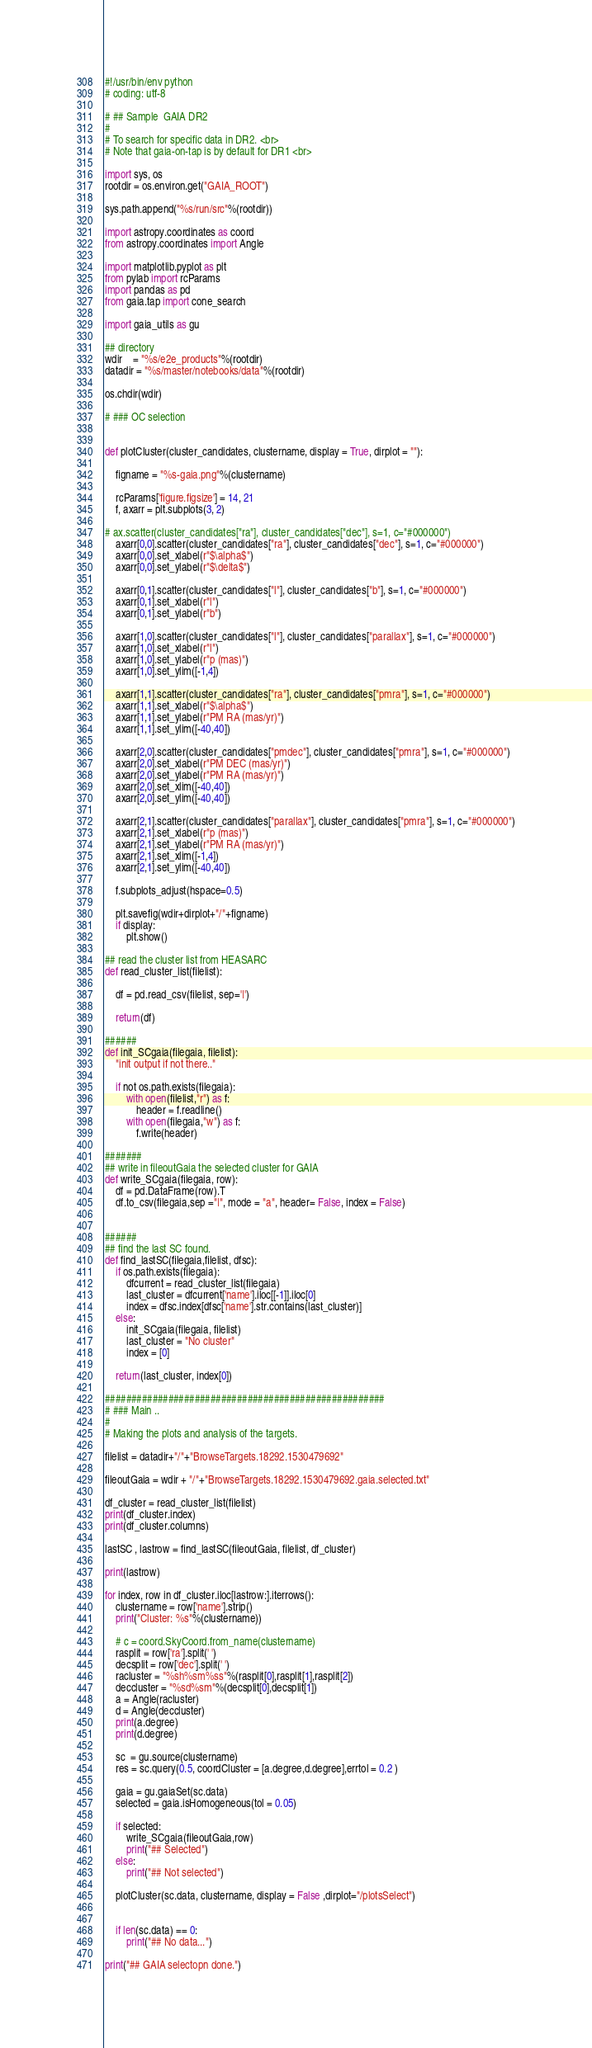<code> <loc_0><loc_0><loc_500><loc_500><_Python_>#!/usr/bin/env python
# coding: utf-8

# ## Sample  GAIA DR2
#
# To search for specific data in DR2. <br>
# Note that gaia-on-tap is by default for DR1 <br>

import sys, os
rootdir = os.environ.get("GAIA_ROOT")

sys.path.append("%s/run/src"%(rootdir))

import astropy.coordinates as coord
from astropy.coordinates import Angle

import matplotlib.pyplot as plt
from pylab import rcParams
import pandas as pd
from gaia.tap import cone_search

import gaia_utils as gu

## directory
wdir    = "%s/e2e_products"%(rootdir)
datadir = "%s/master/notebooks/data"%(rootdir)

os.chdir(wdir)

# ### OC selection


def plotCluster(cluster_candidates, clustername, display = True, dirplot = ""):

    figname = "%s-gaia.png"%(clustername)

    rcParams['figure.figsize'] = 14, 21
    f, axarr = plt.subplots(3, 2)

# ax.scatter(cluster_candidates["ra"], cluster_candidates["dec"], s=1, c="#000000")
    axarr[0,0].scatter(cluster_candidates["ra"], cluster_candidates["dec"], s=1, c="#000000")
    axarr[0,0].set_xlabel(r"$\alpha$")
    axarr[0,0].set_ylabel(r"$\delta$")

    axarr[0,1].scatter(cluster_candidates["l"], cluster_candidates["b"], s=1, c="#000000")
    axarr[0,1].set_xlabel(r"l")
    axarr[0,1].set_ylabel(r"b")

    axarr[1,0].scatter(cluster_candidates["l"], cluster_candidates["parallax"], s=1, c="#000000")
    axarr[1,0].set_xlabel(r"l")
    axarr[1,0].set_ylabel(r"p (mas)")
    axarr[1,0].set_ylim([-1,4])

    axarr[1,1].scatter(cluster_candidates["ra"], cluster_candidates["pmra"], s=1, c="#000000")
    axarr[1,1].set_xlabel(r"$\alpha$")
    axarr[1,1].set_ylabel(r"PM RA (mas/yr)")
    axarr[1,1].set_ylim([-40,40])

    axarr[2,0].scatter(cluster_candidates["pmdec"], cluster_candidates["pmra"], s=1, c="#000000")
    axarr[2,0].set_xlabel(r"PM DEC (mas/yr)")
    axarr[2,0].set_ylabel(r"PM RA (mas/yr)")
    axarr[2,0].set_xlim([-40,40])
    axarr[2,0].set_ylim([-40,40])

    axarr[2,1].scatter(cluster_candidates["parallax"], cluster_candidates["pmra"], s=1, c="#000000")
    axarr[2,1].set_xlabel(r"p (mas)")
    axarr[2,1].set_ylabel(r"PM RA (mas/yr)")
    axarr[2,1].set_xlim([-1,4])
    axarr[2,1].set_ylim([-40,40])

    f.subplots_adjust(hspace=0.5)

    plt.savefig(wdir+dirplot+"/"+figname)
    if display:
        plt.show()

## read the cluster list from HEASARC
def read_cluster_list(filelist):

    df = pd.read_csv(filelist, sep='|')

    return(df)

######
def init_SCgaia(filegaia, filelist):
    "init output if not there.."

    if not os.path.exists(filegaia):
        with open(filelist,"r") as f:
            header = f.readline()
        with open(filegaia,"w") as f:
            f.write(header)

#######
## write in fileoutGaia the selected cluster for GAIA
def write_SCgaia(filegaia, row):
    df = pd.DataFrame(row).T
    df.to_csv(filegaia,sep ="|", mode = "a", header= False, index = False)


######
## find the last SC found.
def find_lastSC(filegaia,filelist, dfsc):
    if os.path.exists(filegaia):
        dfcurrent = read_cluster_list(filegaia)
        last_cluster = dfcurrent['name'].iloc[[-1]].iloc[0]
        index = dfsc.index[dfsc['name'].str.contains(last_cluster)]
    else:
        init_SCgaia(filegaia, filelist)
        last_cluster = "No cluster"
        index = [0]

    return(last_cluster, index[0])

#####################################################
# ### Main ..
#
# Making the plots and analysis of the targets.

filelist = datadir+"/"+"BrowseTargets.18292.1530479692"

fileoutGaia = wdir + "/"+"BrowseTargets.18292.1530479692.gaia.selected.txt"

df_cluster = read_cluster_list(filelist)
print(df_cluster.index)
print(df_cluster.columns)

lastSC , lastrow = find_lastSC(fileoutGaia, filelist, df_cluster)

print(lastrow)

for index, row in df_cluster.iloc[lastrow:].iterrows():
    clustername = row['name'].strip()
    print("Cluster: %s"%(clustername))

    # c = coord.SkyCoord.from_name(clustername)
    rasplit = row['ra'].split(' ')
    decsplit = row['dec'].split(' ')
    racluster = "%sh%sm%ss"%(rasplit[0],rasplit[1],rasplit[2])
    deccluster = "%sd%sm"%(decsplit[0],decsplit[1])
    a = Angle(racluster)
    d = Angle(deccluster)
    print(a.degree)
    print(d.degree)

    sc  = gu.source(clustername)
    res = sc.query(0.5, coordCluster = [a.degree,d.degree],errtol = 0.2 )

    gaia = gu.gaiaSet(sc.data)
    selected = gaia.isHomogeneous(tol = 0.05)

    if selected:
        write_SCgaia(fileoutGaia,row)
        print("## Selected")
    else:
        print("## Not selected")

    plotCluster(sc.data, clustername, display = False ,dirplot="/plotsSelect")


    if len(sc.data) == 0:
        print("## No data...")

print("## GAIA selectopn done.")
</code> 